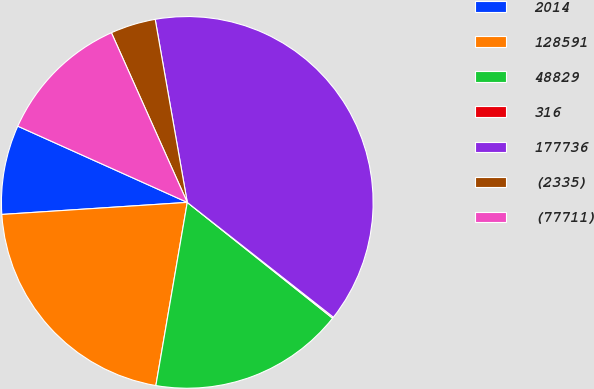<chart> <loc_0><loc_0><loc_500><loc_500><pie_chart><fcel>2014<fcel>128591<fcel>48829<fcel>316<fcel>177736<fcel>(2335)<fcel>(77711)<nl><fcel>7.76%<fcel>21.26%<fcel>16.99%<fcel>0.11%<fcel>38.36%<fcel>3.93%<fcel>11.58%<nl></chart> 